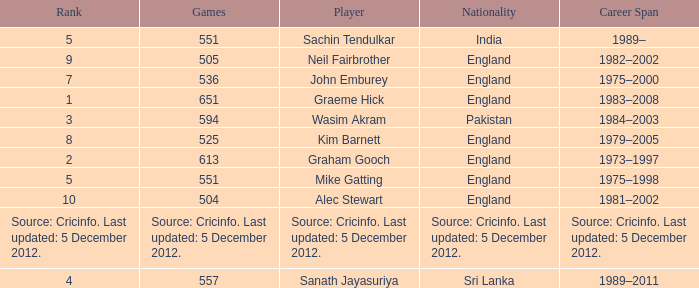What is the origin of mike gatting, who took part in 551 games? England. 